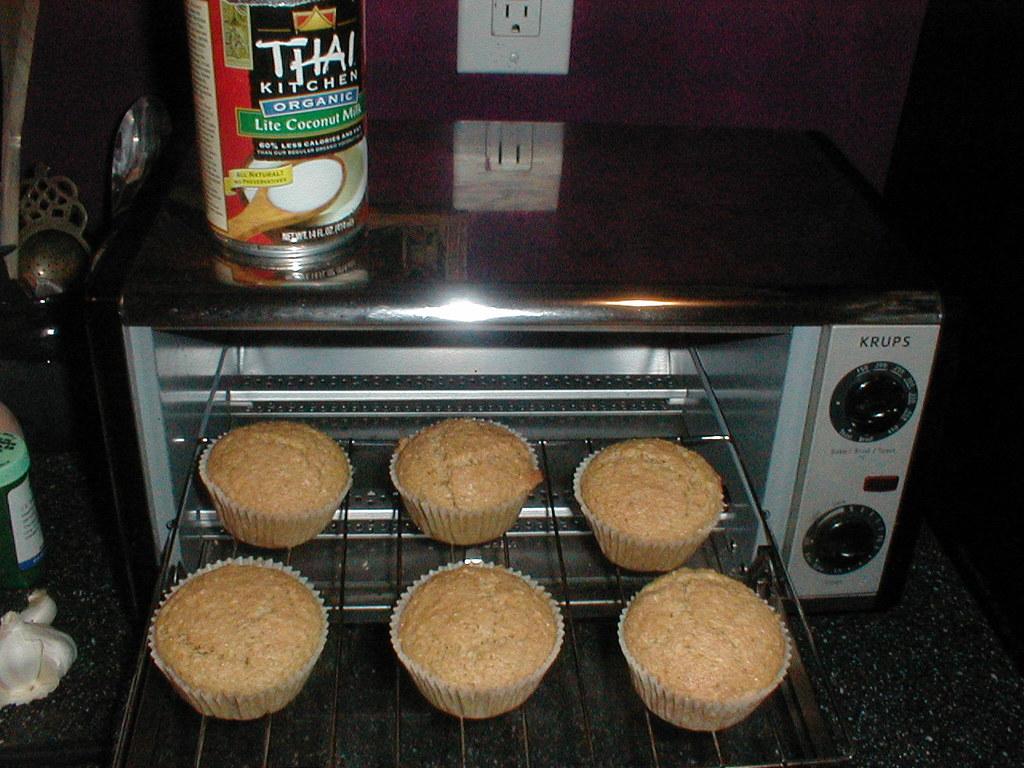How many cupcakes are in the oven/?
Provide a short and direct response. Answering does not require reading text in the image. What brand name is written on the can?
Your response must be concise. Thai kitchen. 